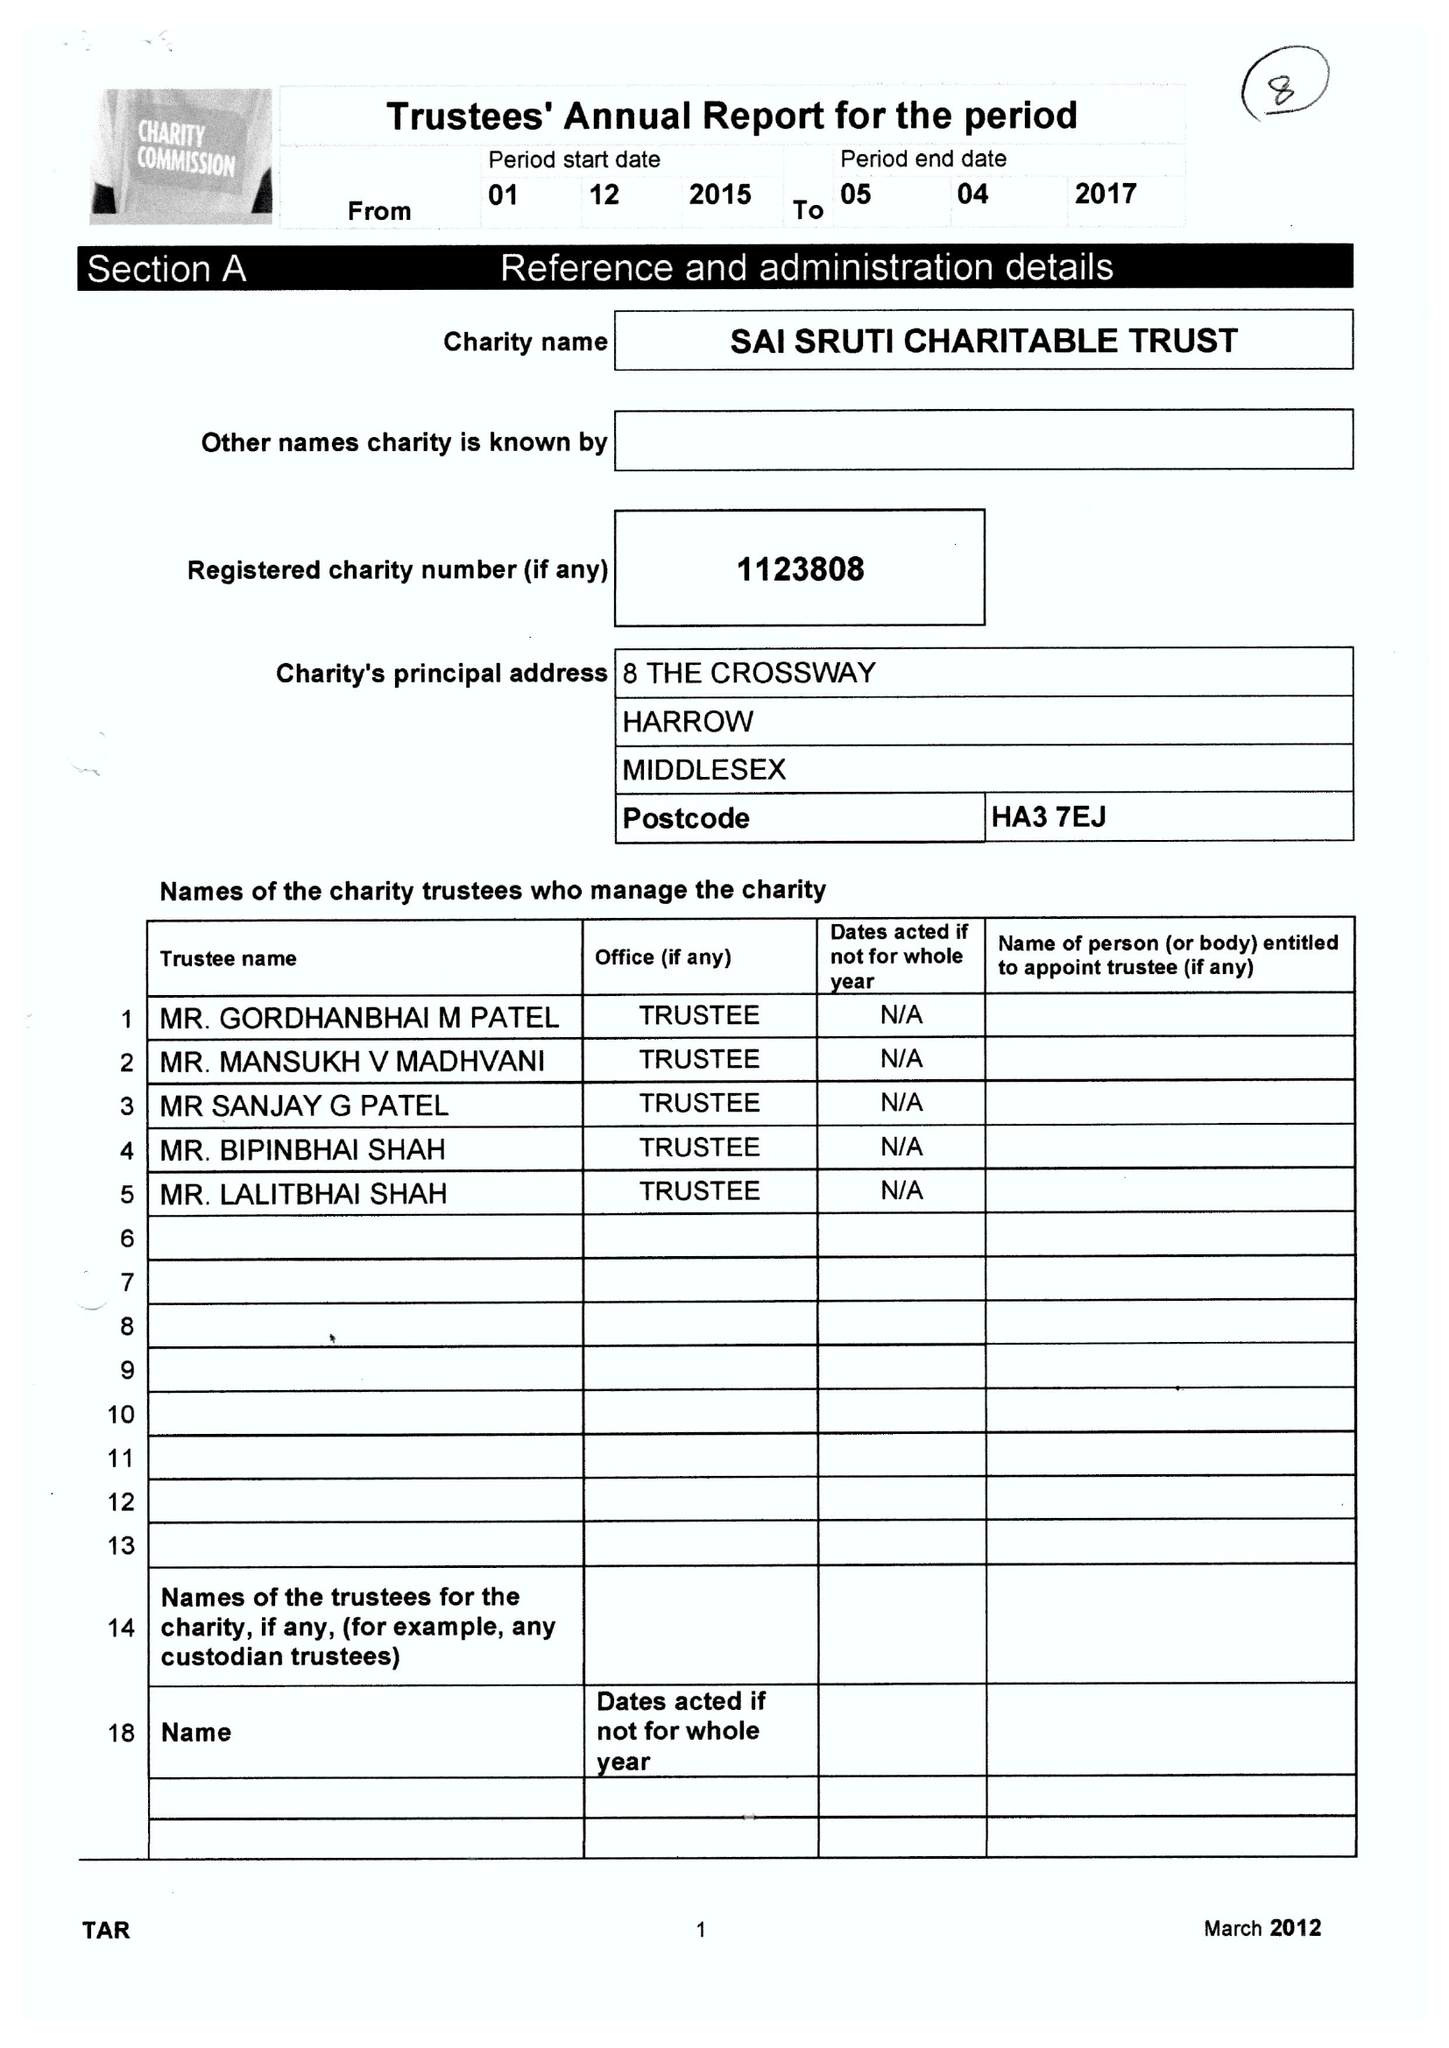What is the value for the spending_annually_in_british_pounds?
Answer the question using a single word or phrase. 89295.00 